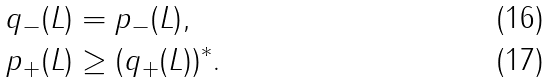<formula> <loc_0><loc_0><loc_500><loc_500>q _ { - } ( L ) & = p _ { - } ( L ) , \\ p _ { + } ( L ) & \geq ( q _ { + } ( L ) ) ^ { * } .</formula> 